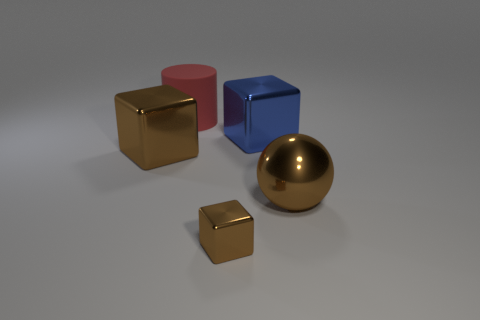The tiny cube that is made of the same material as the brown ball is what color?
Your answer should be very brief. Brown. Does the brown block that is on the right side of the large cylinder have the same material as the big block that is on the left side of the blue block?
Offer a very short reply. Yes. Are there any purple rubber cylinders that have the same size as the brown ball?
Offer a very short reply. No. What size is the brown cube that is behind the brown object right of the small cube?
Keep it short and to the point. Large. What number of large metal things are the same color as the big shiny sphere?
Provide a succinct answer. 1. The brown metal thing on the right side of the shiny thing in front of the big metal sphere is what shape?
Ensure brevity in your answer.  Sphere. What number of small cubes have the same material as the ball?
Ensure brevity in your answer.  1. What material is the big red cylinder that is behind the big brown shiny block?
Your answer should be compact. Rubber. There is a metallic thing that is left of the metal cube that is in front of the large brown metallic thing that is to the right of the blue shiny thing; what shape is it?
Your answer should be very brief. Cube. There is a shiny block to the left of the big red rubber cylinder; is its color the same as the metallic sphere that is right of the large brown block?
Keep it short and to the point. Yes. 